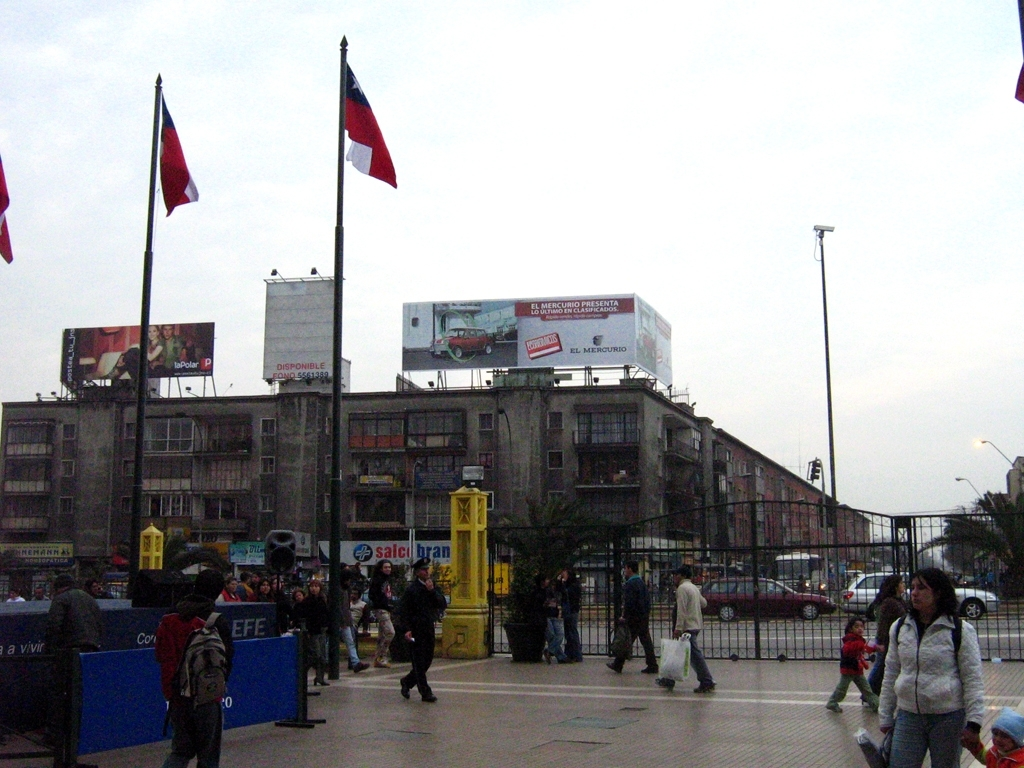Are there any quality issues with this image? Yes, the image exhibits several quality issues. Notably, it appears to be taken under overcast conditions which results in flat lighting and muted colors. Additionally, the resolution is relatively low, making details less sharp. Some parts of the image, especially distant objects like signs and billboards, are grainy, which further detracts from the overall clarity. 